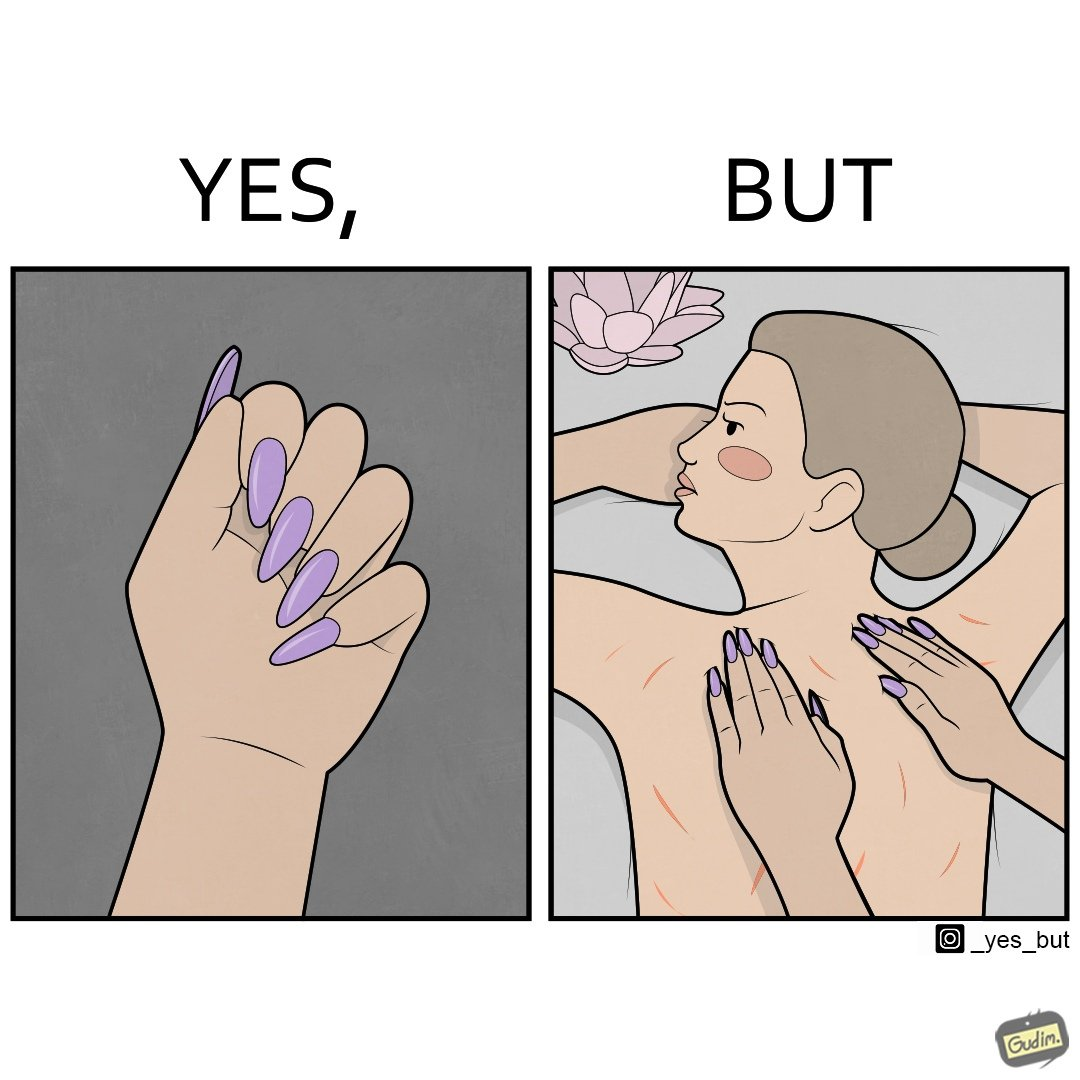Is this image satirical or non-satirical? Yes, this image is satirical. 